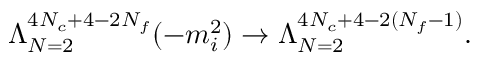Convert formula to latex. <formula><loc_0><loc_0><loc_500><loc_500>\Lambda _ { N = 2 } ^ { 4 N _ { c } + 4 - 2 N _ { f } } ( - m _ { i } ^ { 2 } ) \rightarrow \Lambda _ { N = 2 } ^ { 4 N _ { c } + 4 - 2 ( N _ { f } - 1 ) } .</formula> 